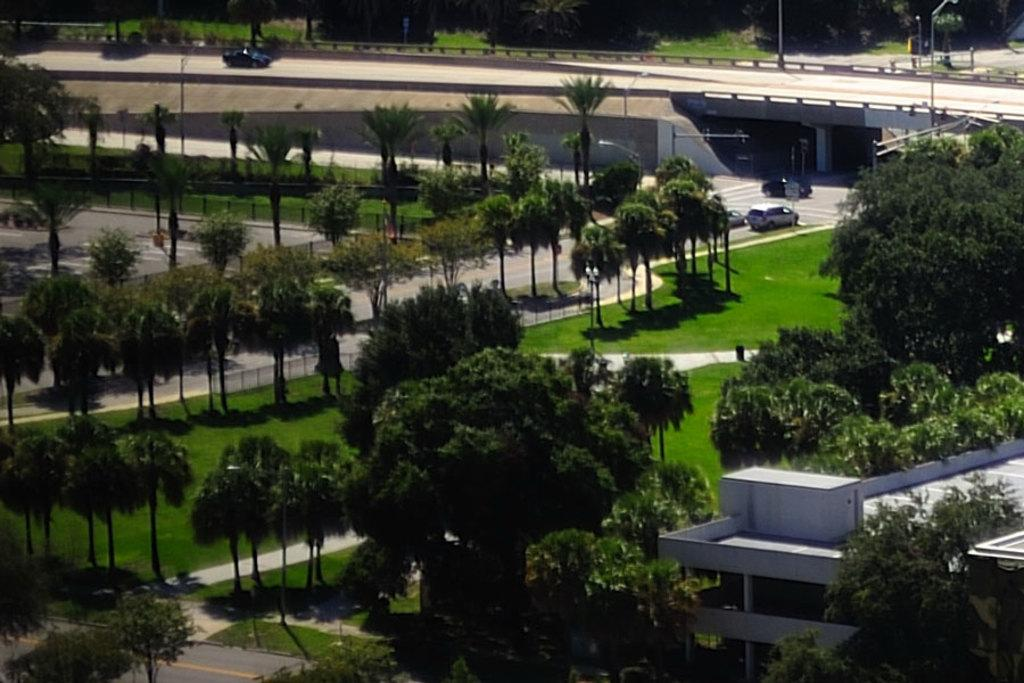What type of natural elements can be seen in the image? There are trees and plants in the image. What type of structure is present in the image? There is a bridge and a house in the image. What are the poles used for in the image? The poles are likely used for supporting wires or other infrastructure. What type of transportation is visible in the image? There are vehicles on the road in the image. What type of cherry is being served for dinner in the image? There is no dinner or cherry present in the image. What is the cause of the bridge collapsing in the image? There is no indication of a bridge collapse in the image. 